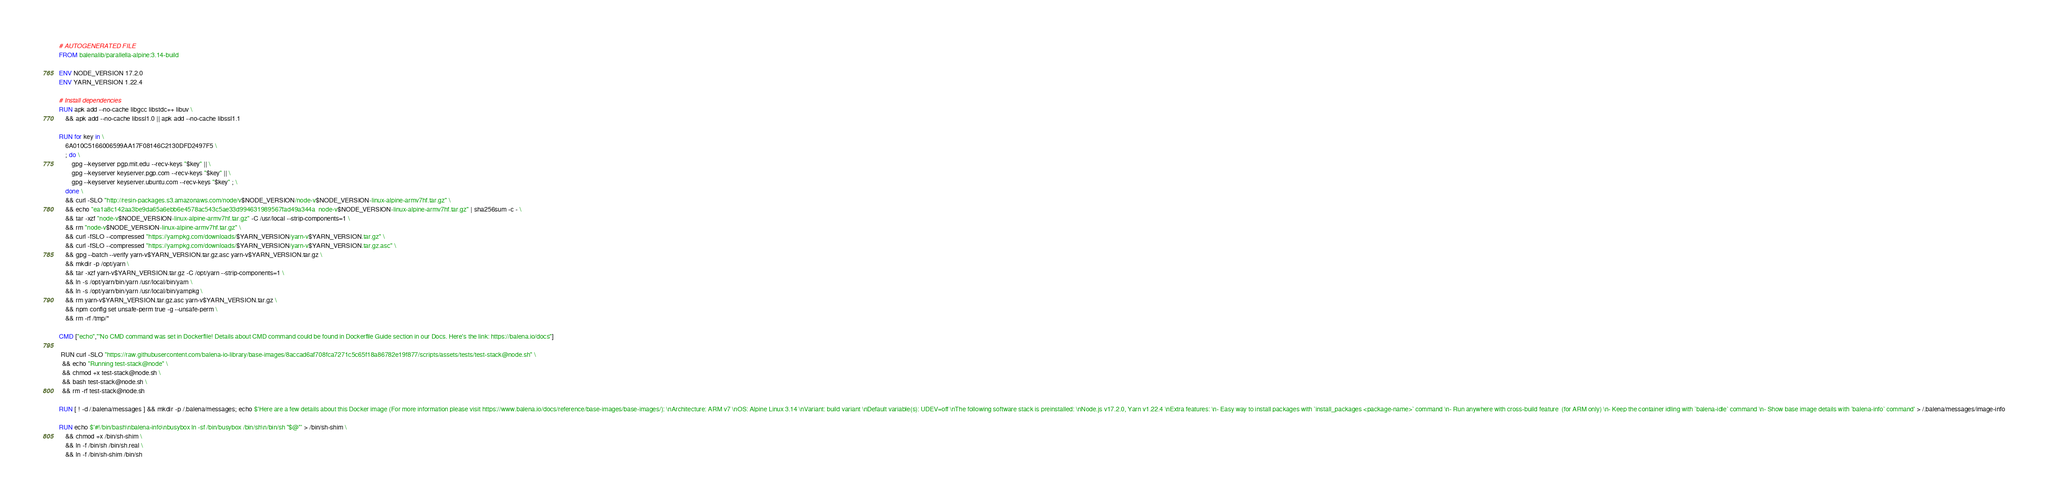Convert code to text. <code><loc_0><loc_0><loc_500><loc_500><_Dockerfile_># AUTOGENERATED FILE
FROM balenalib/parallella-alpine:3.14-build

ENV NODE_VERSION 17.2.0
ENV YARN_VERSION 1.22.4

# Install dependencies
RUN apk add --no-cache libgcc libstdc++ libuv \
	&& apk add --no-cache libssl1.0 || apk add --no-cache libssl1.1

RUN for key in \
	6A010C5166006599AA17F08146C2130DFD2497F5 \
	; do \
		gpg --keyserver pgp.mit.edu --recv-keys "$key" || \
		gpg --keyserver keyserver.pgp.com --recv-keys "$key" || \
		gpg --keyserver keyserver.ubuntu.com --recv-keys "$key" ; \
	done \
	&& curl -SLO "http://resin-packages.s3.amazonaws.com/node/v$NODE_VERSION/node-v$NODE_VERSION-linux-alpine-armv7hf.tar.gz" \
	&& echo "ea1a8c142aa3be9da65a6ebb6e4578ac543c5ae33d994631989567fad49a344a  node-v$NODE_VERSION-linux-alpine-armv7hf.tar.gz" | sha256sum -c - \
	&& tar -xzf "node-v$NODE_VERSION-linux-alpine-armv7hf.tar.gz" -C /usr/local --strip-components=1 \
	&& rm "node-v$NODE_VERSION-linux-alpine-armv7hf.tar.gz" \
	&& curl -fSLO --compressed "https://yarnpkg.com/downloads/$YARN_VERSION/yarn-v$YARN_VERSION.tar.gz" \
	&& curl -fSLO --compressed "https://yarnpkg.com/downloads/$YARN_VERSION/yarn-v$YARN_VERSION.tar.gz.asc" \
	&& gpg --batch --verify yarn-v$YARN_VERSION.tar.gz.asc yarn-v$YARN_VERSION.tar.gz \
	&& mkdir -p /opt/yarn \
	&& tar -xzf yarn-v$YARN_VERSION.tar.gz -C /opt/yarn --strip-components=1 \
	&& ln -s /opt/yarn/bin/yarn /usr/local/bin/yarn \
	&& ln -s /opt/yarn/bin/yarn /usr/local/bin/yarnpkg \
	&& rm yarn-v$YARN_VERSION.tar.gz.asc yarn-v$YARN_VERSION.tar.gz \
	&& npm config set unsafe-perm true -g --unsafe-perm \
	&& rm -rf /tmp/*

CMD ["echo","'No CMD command was set in Dockerfile! Details about CMD command could be found in Dockerfile Guide section in our Docs. Here's the link: https://balena.io/docs"]

 RUN curl -SLO "https://raw.githubusercontent.com/balena-io-library/base-images/8accad6af708fca7271c5c65f18a86782e19f877/scripts/assets/tests/test-stack@node.sh" \
  && echo "Running test-stack@node" \
  && chmod +x test-stack@node.sh \
  && bash test-stack@node.sh \
  && rm -rf test-stack@node.sh 

RUN [ ! -d /.balena/messages ] && mkdir -p /.balena/messages; echo $'Here are a few details about this Docker image (For more information please visit https://www.balena.io/docs/reference/base-images/base-images/): \nArchitecture: ARM v7 \nOS: Alpine Linux 3.14 \nVariant: build variant \nDefault variable(s): UDEV=off \nThe following software stack is preinstalled: \nNode.js v17.2.0, Yarn v1.22.4 \nExtra features: \n- Easy way to install packages with `install_packages <package-name>` command \n- Run anywhere with cross-build feature  (for ARM only) \n- Keep the container idling with `balena-idle` command \n- Show base image details with `balena-info` command' > /.balena/messages/image-info

RUN echo $'#!/bin/bash\nbalena-info\nbusybox ln -sf /bin/busybox /bin/sh\n/bin/sh "$@"' > /bin/sh-shim \
	&& chmod +x /bin/sh-shim \
	&& ln -f /bin/sh /bin/sh.real \
	&& ln -f /bin/sh-shim /bin/sh</code> 